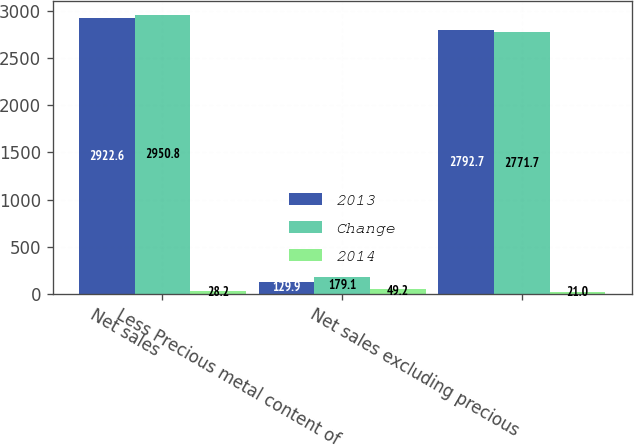Convert chart to OTSL. <chart><loc_0><loc_0><loc_500><loc_500><stacked_bar_chart><ecel><fcel>Net sales<fcel>Less Precious metal content of<fcel>Net sales excluding precious<nl><fcel>2013<fcel>2922.6<fcel>129.9<fcel>2792.7<nl><fcel>Change<fcel>2950.8<fcel>179.1<fcel>2771.7<nl><fcel>2014<fcel>28.2<fcel>49.2<fcel>21<nl></chart> 